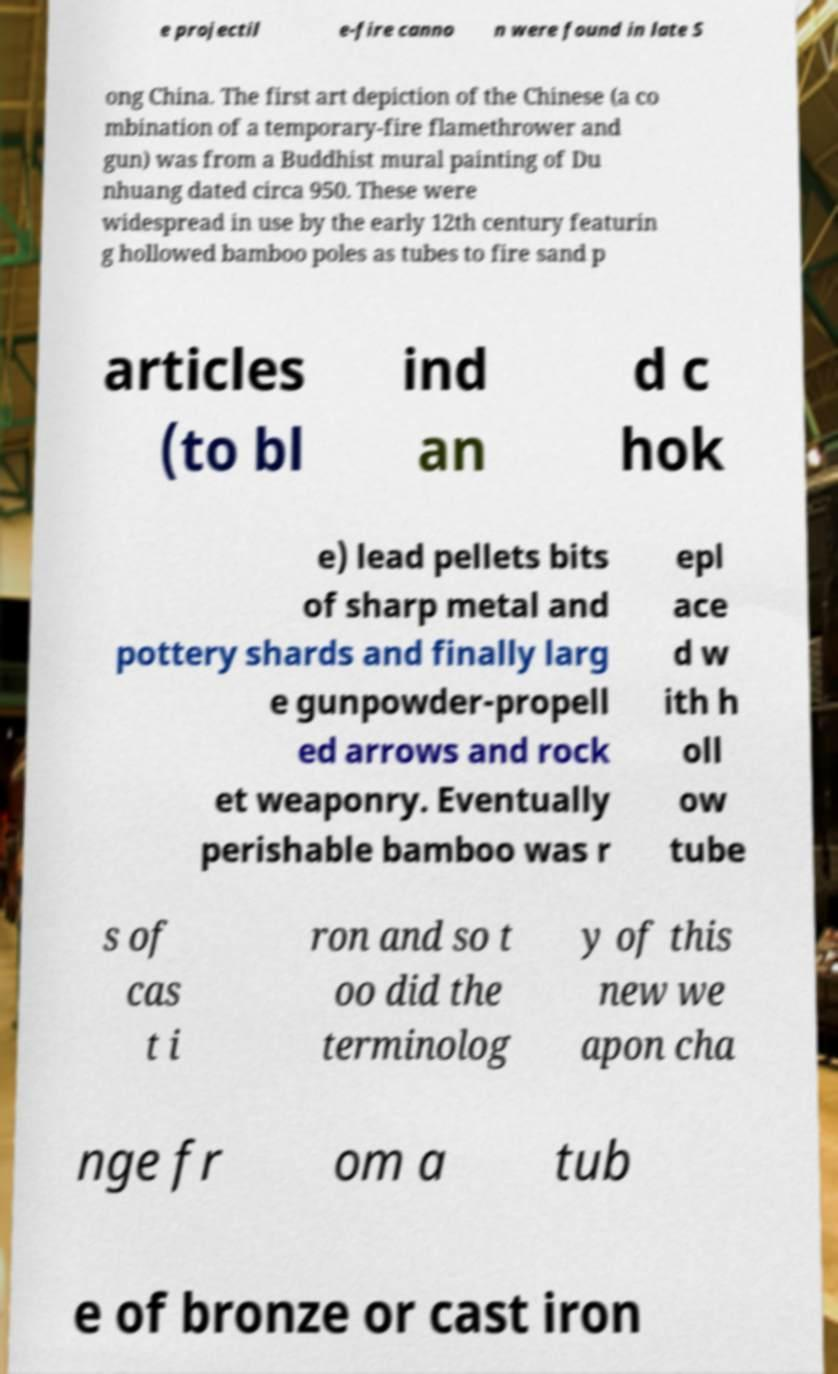There's text embedded in this image that I need extracted. Can you transcribe it verbatim? e projectil e-fire canno n were found in late S ong China. The first art depiction of the Chinese (a co mbination of a temporary-fire flamethrower and gun) was from a Buddhist mural painting of Du nhuang dated circa 950. These were widespread in use by the early 12th century featurin g hollowed bamboo poles as tubes to fire sand p articles (to bl ind an d c hok e) lead pellets bits of sharp metal and pottery shards and finally larg e gunpowder-propell ed arrows and rock et weaponry. Eventually perishable bamboo was r epl ace d w ith h oll ow tube s of cas t i ron and so t oo did the terminolog y of this new we apon cha nge fr om a tub e of bronze or cast iron 